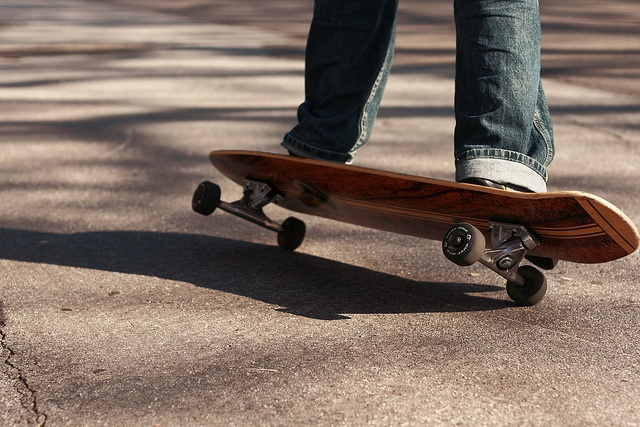Describe the objects in this image and their specific colors. I can see skateboard in gray, black, and maroon tones and people in gray, black, darkgray, and lightgray tones in this image. 